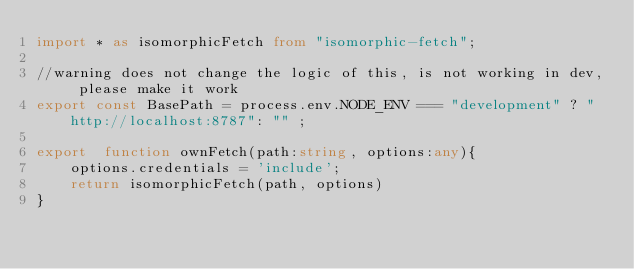Convert code to text. <code><loc_0><loc_0><loc_500><loc_500><_TypeScript_>import * as isomorphicFetch from "isomorphic-fetch";

//warning does not change the logic of this, is not working in dev, please make it work
export const BasePath = process.env.NODE_ENV === "development" ? "http://localhost:8787": "" ;

export  function ownFetch(path:string, options:any){
    options.credentials = 'include';
    return isomorphicFetch(path, options)
}</code> 